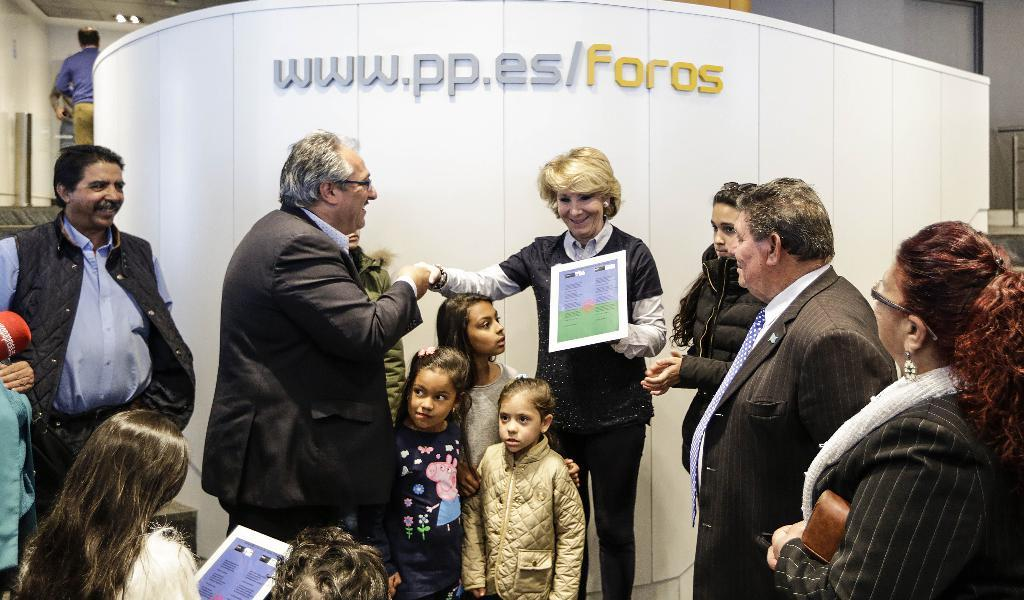How many people are in the image? There are people in the image, but the exact number is not specified. What are some people doing in the image? Some people are holding objects in the image. Can you describe the object with text in the image? There is an object with text in the image, but its specific appearance or content is not mentioned. What type of structure is visible in the image? There is a wall in the image, and there is also a roof with lights. What type of bead is being used by the son in the image? There is no mention of a bead or a son in the image, so this question cannot be answered. 